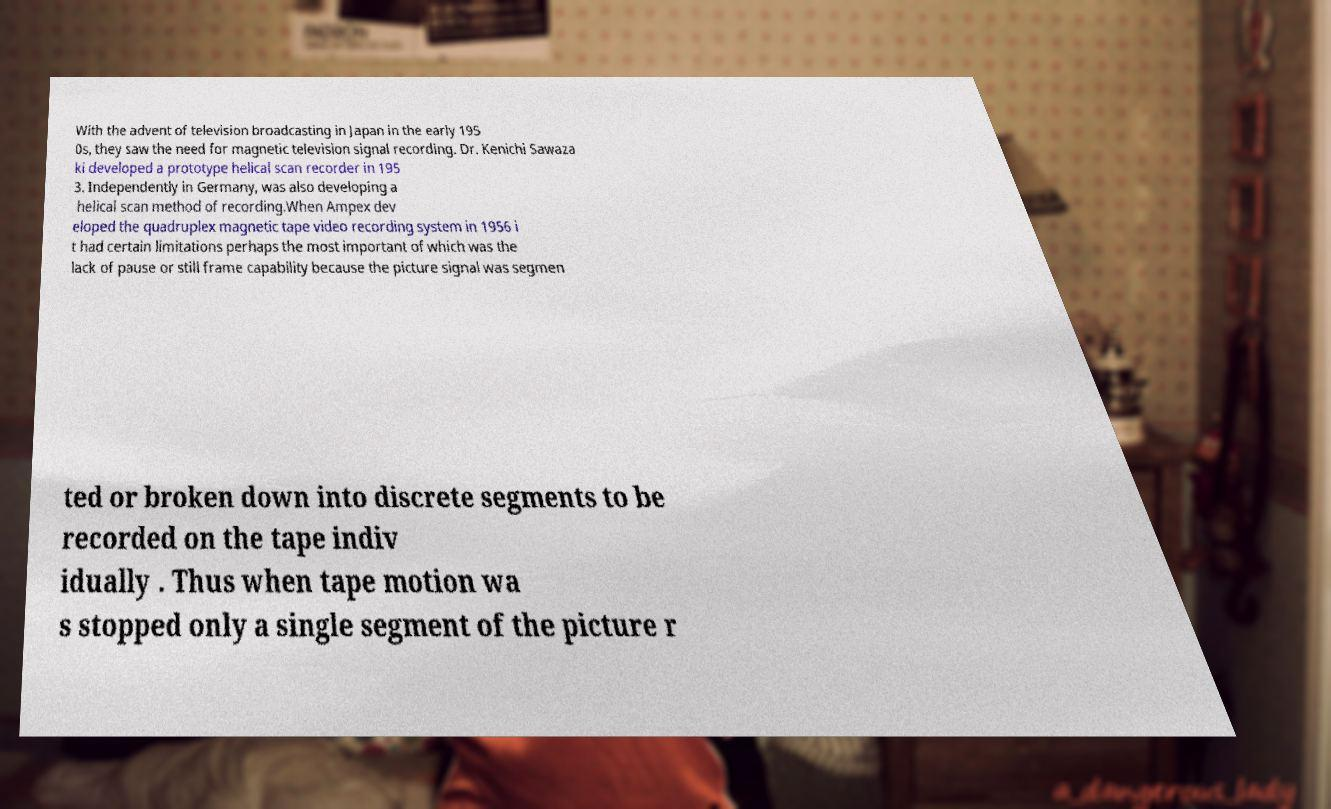Can you read and provide the text displayed in the image?This photo seems to have some interesting text. Can you extract and type it out for me? With the advent of television broadcasting in Japan in the early 195 0s, they saw the need for magnetic television signal recording. Dr. Kenichi Sawaza ki developed a prototype helical scan recorder in 195 3. Independently in Germany, was also developing a helical scan method of recording.When Ampex dev eloped the quadruplex magnetic tape video recording system in 1956 i t had certain limitations perhaps the most important of which was the lack of pause or still frame capability because the picture signal was segmen ted or broken down into discrete segments to be recorded on the tape indiv idually . Thus when tape motion wa s stopped only a single segment of the picture r 